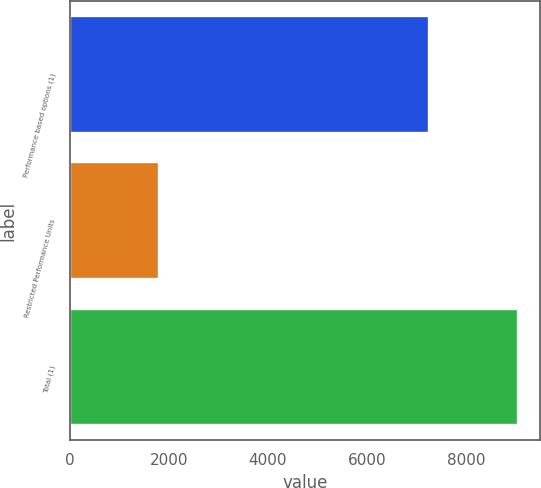<chart> <loc_0><loc_0><loc_500><loc_500><bar_chart><fcel>Performance based options (1)<fcel>Restricted Performance Units<fcel>Total (1)<nl><fcel>7247<fcel>1798<fcel>9045<nl></chart> 